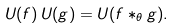Convert formula to latex. <formula><loc_0><loc_0><loc_500><loc_500>U ( f ) \, U ( g ) = U ( f * _ { \theta } g ) .</formula> 